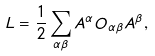<formula> <loc_0><loc_0><loc_500><loc_500>L = \frac { 1 } { 2 } \sum _ { \alpha \beta } A ^ { \alpha } O _ { \alpha \beta } A ^ { \beta } ,</formula> 